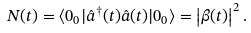<formula> <loc_0><loc_0><loc_500><loc_500>N ( t ) = \langle 0 _ { 0 } | \hat { a } ^ { \dagger } ( t ) \hat { a } ( t ) | 0 _ { 0 } \rangle = \left | \beta ( t ) \right | ^ { 2 } .</formula> 